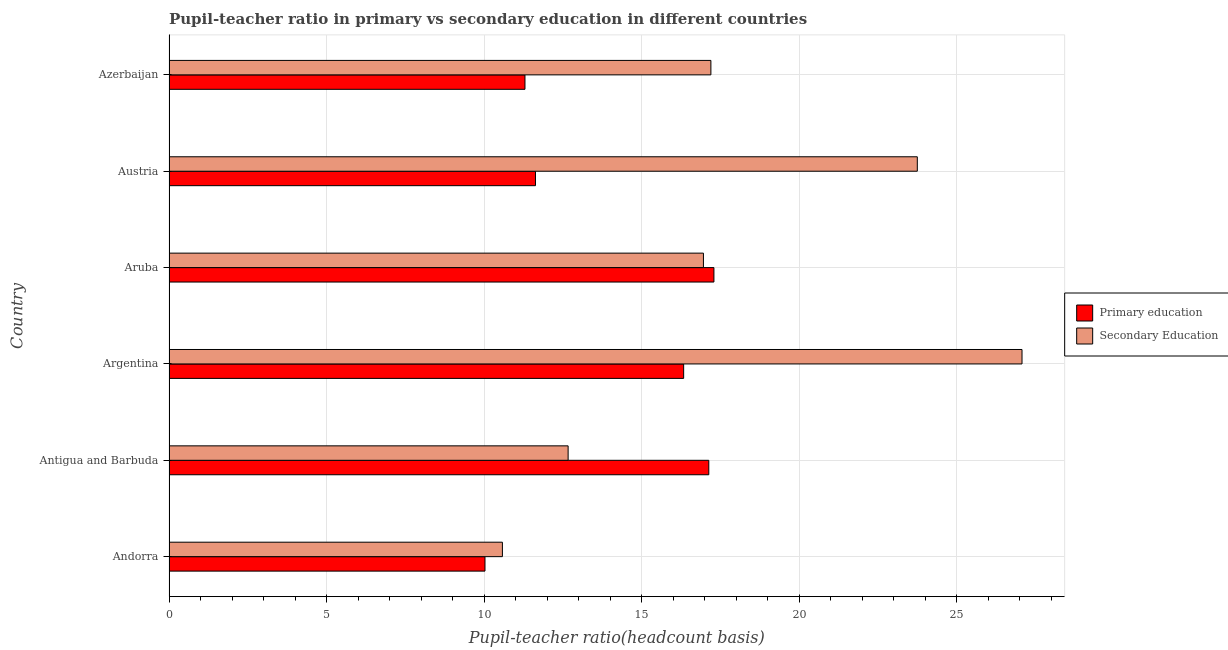How many different coloured bars are there?
Your answer should be very brief. 2. How many groups of bars are there?
Your answer should be very brief. 6. Are the number of bars per tick equal to the number of legend labels?
Your answer should be compact. Yes. Are the number of bars on each tick of the Y-axis equal?
Your answer should be very brief. Yes. How many bars are there on the 3rd tick from the top?
Keep it short and to the point. 2. What is the label of the 5th group of bars from the top?
Provide a short and direct response. Antigua and Barbuda. In how many cases, is the number of bars for a given country not equal to the number of legend labels?
Your response must be concise. 0. What is the pupil-teacher ratio in primary education in Azerbaijan?
Offer a terse response. 11.3. Across all countries, what is the maximum pupil teacher ratio on secondary education?
Offer a very short reply. 27.07. Across all countries, what is the minimum pupil teacher ratio on secondary education?
Keep it short and to the point. 10.58. In which country was the pupil teacher ratio on secondary education maximum?
Your response must be concise. Argentina. In which country was the pupil-teacher ratio in primary education minimum?
Your answer should be very brief. Andorra. What is the total pupil teacher ratio on secondary education in the graph?
Provide a short and direct response. 108.21. What is the difference between the pupil-teacher ratio in primary education in Antigua and Barbuda and that in Argentina?
Your answer should be compact. 0.8. What is the difference between the pupil-teacher ratio in primary education in Antigua and Barbuda and the pupil teacher ratio on secondary education in Aruba?
Your answer should be compact. 0.17. What is the average pupil teacher ratio on secondary education per country?
Provide a short and direct response. 18.04. What is the difference between the pupil-teacher ratio in primary education and pupil teacher ratio on secondary education in Azerbaijan?
Offer a terse response. -5.9. What is the ratio of the pupil teacher ratio on secondary education in Austria to that in Azerbaijan?
Ensure brevity in your answer.  1.38. Is the difference between the pupil-teacher ratio in primary education in Andorra and Azerbaijan greater than the difference between the pupil teacher ratio on secondary education in Andorra and Azerbaijan?
Provide a short and direct response. Yes. What is the difference between the highest and the second highest pupil teacher ratio on secondary education?
Give a very brief answer. 3.32. What is the difference between the highest and the lowest pupil teacher ratio on secondary education?
Ensure brevity in your answer.  16.49. What does the 1st bar from the top in Andorra represents?
Make the answer very short. Secondary Education. What does the 2nd bar from the bottom in Andorra represents?
Your answer should be very brief. Secondary Education. Are all the bars in the graph horizontal?
Your response must be concise. Yes. How many countries are there in the graph?
Ensure brevity in your answer.  6. What is the difference between two consecutive major ticks on the X-axis?
Provide a short and direct response. 5. Does the graph contain any zero values?
Offer a very short reply. No. Where does the legend appear in the graph?
Provide a succinct answer. Center right. What is the title of the graph?
Provide a short and direct response. Pupil-teacher ratio in primary vs secondary education in different countries. What is the label or title of the X-axis?
Make the answer very short. Pupil-teacher ratio(headcount basis). What is the label or title of the Y-axis?
Keep it short and to the point. Country. What is the Pupil-teacher ratio(headcount basis) in Primary education in Andorra?
Keep it short and to the point. 10.03. What is the Pupil-teacher ratio(headcount basis) of Secondary Education in Andorra?
Make the answer very short. 10.58. What is the Pupil-teacher ratio(headcount basis) in Primary education in Antigua and Barbuda?
Provide a succinct answer. 17.13. What is the Pupil-teacher ratio(headcount basis) in Secondary Education in Antigua and Barbuda?
Provide a succinct answer. 12.67. What is the Pupil-teacher ratio(headcount basis) in Primary education in Argentina?
Your answer should be very brief. 16.33. What is the Pupil-teacher ratio(headcount basis) in Secondary Education in Argentina?
Offer a very short reply. 27.07. What is the Pupil-teacher ratio(headcount basis) of Primary education in Aruba?
Your answer should be very brief. 17.29. What is the Pupil-teacher ratio(headcount basis) in Secondary Education in Aruba?
Keep it short and to the point. 16.96. What is the Pupil-teacher ratio(headcount basis) in Primary education in Austria?
Offer a very short reply. 11.63. What is the Pupil-teacher ratio(headcount basis) of Secondary Education in Austria?
Provide a succinct answer. 23.75. What is the Pupil-teacher ratio(headcount basis) of Primary education in Azerbaijan?
Your response must be concise. 11.3. What is the Pupil-teacher ratio(headcount basis) in Secondary Education in Azerbaijan?
Make the answer very short. 17.2. Across all countries, what is the maximum Pupil-teacher ratio(headcount basis) of Primary education?
Keep it short and to the point. 17.29. Across all countries, what is the maximum Pupil-teacher ratio(headcount basis) of Secondary Education?
Offer a very short reply. 27.07. Across all countries, what is the minimum Pupil-teacher ratio(headcount basis) in Primary education?
Provide a short and direct response. 10.03. Across all countries, what is the minimum Pupil-teacher ratio(headcount basis) in Secondary Education?
Make the answer very short. 10.58. What is the total Pupil-teacher ratio(headcount basis) in Primary education in the graph?
Offer a terse response. 83.7. What is the total Pupil-teacher ratio(headcount basis) of Secondary Education in the graph?
Give a very brief answer. 108.21. What is the difference between the Pupil-teacher ratio(headcount basis) of Primary education in Andorra and that in Antigua and Barbuda?
Your answer should be compact. -7.1. What is the difference between the Pupil-teacher ratio(headcount basis) of Secondary Education in Andorra and that in Antigua and Barbuda?
Offer a terse response. -2.09. What is the difference between the Pupil-teacher ratio(headcount basis) of Primary education in Andorra and that in Argentina?
Your answer should be very brief. -6.3. What is the difference between the Pupil-teacher ratio(headcount basis) of Secondary Education in Andorra and that in Argentina?
Your answer should be very brief. -16.49. What is the difference between the Pupil-teacher ratio(headcount basis) of Primary education in Andorra and that in Aruba?
Give a very brief answer. -7.27. What is the difference between the Pupil-teacher ratio(headcount basis) in Secondary Education in Andorra and that in Aruba?
Provide a short and direct response. -6.38. What is the difference between the Pupil-teacher ratio(headcount basis) in Primary education in Andorra and that in Austria?
Offer a very short reply. -1.6. What is the difference between the Pupil-teacher ratio(headcount basis) of Secondary Education in Andorra and that in Austria?
Offer a terse response. -13.17. What is the difference between the Pupil-teacher ratio(headcount basis) in Primary education in Andorra and that in Azerbaijan?
Make the answer very short. -1.27. What is the difference between the Pupil-teacher ratio(headcount basis) of Secondary Education in Andorra and that in Azerbaijan?
Ensure brevity in your answer.  -6.62. What is the difference between the Pupil-teacher ratio(headcount basis) of Primary education in Antigua and Barbuda and that in Argentina?
Give a very brief answer. 0.8. What is the difference between the Pupil-teacher ratio(headcount basis) in Secondary Education in Antigua and Barbuda and that in Argentina?
Offer a terse response. -14.4. What is the difference between the Pupil-teacher ratio(headcount basis) in Primary education in Antigua and Barbuda and that in Aruba?
Your response must be concise. -0.16. What is the difference between the Pupil-teacher ratio(headcount basis) in Secondary Education in Antigua and Barbuda and that in Aruba?
Your answer should be compact. -4.29. What is the difference between the Pupil-teacher ratio(headcount basis) of Primary education in Antigua and Barbuda and that in Austria?
Offer a terse response. 5.5. What is the difference between the Pupil-teacher ratio(headcount basis) of Secondary Education in Antigua and Barbuda and that in Austria?
Your response must be concise. -11.08. What is the difference between the Pupil-teacher ratio(headcount basis) in Primary education in Antigua and Barbuda and that in Azerbaijan?
Provide a short and direct response. 5.83. What is the difference between the Pupil-teacher ratio(headcount basis) in Secondary Education in Antigua and Barbuda and that in Azerbaijan?
Your answer should be compact. -4.53. What is the difference between the Pupil-teacher ratio(headcount basis) of Primary education in Argentina and that in Aruba?
Your answer should be compact. -0.96. What is the difference between the Pupil-teacher ratio(headcount basis) of Secondary Education in Argentina and that in Aruba?
Provide a succinct answer. 10.11. What is the difference between the Pupil-teacher ratio(headcount basis) in Primary education in Argentina and that in Austria?
Ensure brevity in your answer.  4.7. What is the difference between the Pupil-teacher ratio(headcount basis) in Secondary Education in Argentina and that in Austria?
Provide a short and direct response. 3.32. What is the difference between the Pupil-teacher ratio(headcount basis) in Primary education in Argentina and that in Azerbaijan?
Your answer should be compact. 5.04. What is the difference between the Pupil-teacher ratio(headcount basis) of Secondary Education in Argentina and that in Azerbaijan?
Provide a short and direct response. 9.87. What is the difference between the Pupil-teacher ratio(headcount basis) of Primary education in Aruba and that in Austria?
Your answer should be compact. 5.66. What is the difference between the Pupil-teacher ratio(headcount basis) in Secondary Education in Aruba and that in Austria?
Your answer should be very brief. -6.79. What is the difference between the Pupil-teacher ratio(headcount basis) of Primary education in Aruba and that in Azerbaijan?
Offer a terse response. 6. What is the difference between the Pupil-teacher ratio(headcount basis) of Secondary Education in Aruba and that in Azerbaijan?
Your response must be concise. -0.24. What is the difference between the Pupil-teacher ratio(headcount basis) of Secondary Education in Austria and that in Azerbaijan?
Provide a short and direct response. 6.55. What is the difference between the Pupil-teacher ratio(headcount basis) in Primary education in Andorra and the Pupil-teacher ratio(headcount basis) in Secondary Education in Antigua and Barbuda?
Your answer should be compact. -2.64. What is the difference between the Pupil-teacher ratio(headcount basis) in Primary education in Andorra and the Pupil-teacher ratio(headcount basis) in Secondary Education in Argentina?
Offer a very short reply. -17.04. What is the difference between the Pupil-teacher ratio(headcount basis) in Primary education in Andorra and the Pupil-teacher ratio(headcount basis) in Secondary Education in Aruba?
Offer a terse response. -6.93. What is the difference between the Pupil-teacher ratio(headcount basis) in Primary education in Andorra and the Pupil-teacher ratio(headcount basis) in Secondary Education in Austria?
Make the answer very short. -13.72. What is the difference between the Pupil-teacher ratio(headcount basis) of Primary education in Andorra and the Pupil-teacher ratio(headcount basis) of Secondary Education in Azerbaijan?
Keep it short and to the point. -7.17. What is the difference between the Pupil-teacher ratio(headcount basis) of Primary education in Antigua and Barbuda and the Pupil-teacher ratio(headcount basis) of Secondary Education in Argentina?
Offer a very short reply. -9.94. What is the difference between the Pupil-teacher ratio(headcount basis) in Primary education in Antigua and Barbuda and the Pupil-teacher ratio(headcount basis) in Secondary Education in Aruba?
Keep it short and to the point. 0.17. What is the difference between the Pupil-teacher ratio(headcount basis) in Primary education in Antigua and Barbuda and the Pupil-teacher ratio(headcount basis) in Secondary Education in Austria?
Make the answer very short. -6.62. What is the difference between the Pupil-teacher ratio(headcount basis) of Primary education in Antigua and Barbuda and the Pupil-teacher ratio(headcount basis) of Secondary Education in Azerbaijan?
Offer a terse response. -0.07. What is the difference between the Pupil-teacher ratio(headcount basis) in Primary education in Argentina and the Pupil-teacher ratio(headcount basis) in Secondary Education in Aruba?
Offer a very short reply. -0.63. What is the difference between the Pupil-teacher ratio(headcount basis) in Primary education in Argentina and the Pupil-teacher ratio(headcount basis) in Secondary Education in Austria?
Provide a short and direct response. -7.41. What is the difference between the Pupil-teacher ratio(headcount basis) in Primary education in Argentina and the Pupil-teacher ratio(headcount basis) in Secondary Education in Azerbaijan?
Your answer should be compact. -0.86. What is the difference between the Pupil-teacher ratio(headcount basis) in Primary education in Aruba and the Pupil-teacher ratio(headcount basis) in Secondary Education in Austria?
Keep it short and to the point. -6.45. What is the difference between the Pupil-teacher ratio(headcount basis) of Primary education in Aruba and the Pupil-teacher ratio(headcount basis) of Secondary Education in Azerbaijan?
Offer a very short reply. 0.1. What is the difference between the Pupil-teacher ratio(headcount basis) of Primary education in Austria and the Pupil-teacher ratio(headcount basis) of Secondary Education in Azerbaijan?
Your answer should be very brief. -5.57. What is the average Pupil-teacher ratio(headcount basis) in Primary education per country?
Give a very brief answer. 13.95. What is the average Pupil-teacher ratio(headcount basis) of Secondary Education per country?
Provide a succinct answer. 18.04. What is the difference between the Pupil-teacher ratio(headcount basis) of Primary education and Pupil-teacher ratio(headcount basis) of Secondary Education in Andorra?
Provide a succinct answer. -0.55. What is the difference between the Pupil-teacher ratio(headcount basis) of Primary education and Pupil-teacher ratio(headcount basis) of Secondary Education in Antigua and Barbuda?
Make the answer very short. 4.46. What is the difference between the Pupil-teacher ratio(headcount basis) of Primary education and Pupil-teacher ratio(headcount basis) of Secondary Education in Argentina?
Offer a very short reply. -10.74. What is the difference between the Pupil-teacher ratio(headcount basis) in Primary education and Pupil-teacher ratio(headcount basis) in Secondary Education in Aruba?
Make the answer very short. 0.33. What is the difference between the Pupil-teacher ratio(headcount basis) of Primary education and Pupil-teacher ratio(headcount basis) of Secondary Education in Austria?
Ensure brevity in your answer.  -12.12. What is the difference between the Pupil-teacher ratio(headcount basis) of Primary education and Pupil-teacher ratio(headcount basis) of Secondary Education in Azerbaijan?
Offer a terse response. -5.9. What is the ratio of the Pupil-teacher ratio(headcount basis) of Primary education in Andorra to that in Antigua and Barbuda?
Provide a short and direct response. 0.59. What is the ratio of the Pupil-teacher ratio(headcount basis) of Secondary Education in Andorra to that in Antigua and Barbuda?
Your answer should be compact. 0.84. What is the ratio of the Pupil-teacher ratio(headcount basis) of Primary education in Andorra to that in Argentina?
Provide a short and direct response. 0.61. What is the ratio of the Pupil-teacher ratio(headcount basis) of Secondary Education in Andorra to that in Argentina?
Give a very brief answer. 0.39. What is the ratio of the Pupil-teacher ratio(headcount basis) in Primary education in Andorra to that in Aruba?
Offer a very short reply. 0.58. What is the ratio of the Pupil-teacher ratio(headcount basis) in Secondary Education in Andorra to that in Aruba?
Provide a succinct answer. 0.62. What is the ratio of the Pupil-teacher ratio(headcount basis) of Primary education in Andorra to that in Austria?
Your response must be concise. 0.86. What is the ratio of the Pupil-teacher ratio(headcount basis) of Secondary Education in Andorra to that in Austria?
Give a very brief answer. 0.45. What is the ratio of the Pupil-teacher ratio(headcount basis) in Primary education in Andorra to that in Azerbaijan?
Offer a very short reply. 0.89. What is the ratio of the Pupil-teacher ratio(headcount basis) in Secondary Education in Andorra to that in Azerbaijan?
Ensure brevity in your answer.  0.62. What is the ratio of the Pupil-teacher ratio(headcount basis) of Primary education in Antigua and Barbuda to that in Argentina?
Your response must be concise. 1.05. What is the ratio of the Pupil-teacher ratio(headcount basis) of Secondary Education in Antigua and Barbuda to that in Argentina?
Make the answer very short. 0.47. What is the ratio of the Pupil-teacher ratio(headcount basis) in Primary education in Antigua and Barbuda to that in Aruba?
Offer a terse response. 0.99. What is the ratio of the Pupil-teacher ratio(headcount basis) of Secondary Education in Antigua and Barbuda to that in Aruba?
Offer a very short reply. 0.75. What is the ratio of the Pupil-teacher ratio(headcount basis) of Primary education in Antigua and Barbuda to that in Austria?
Your answer should be very brief. 1.47. What is the ratio of the Pupil-teacher ratio(headcount basis) in Secondary Education in Antigua and Barbuda to that in Austria?
Your answer should be compact. 0.53. What is the ratio of the Pupil-teacher ratio(headcount basis) of Primary education in Antigua and Barbuda to that in Azerbaijan?
Your answer should be very brief. 1.52. What is the ratio of the Pupil-teacher ratio(headcount basis) of Secondary Education in Antigua and Barbuda to that in Azerbaijan?
Your answer should be compact. 0.74. What is the ratio of the Pupil-teacher ratio(headcount basis) in Primary education in Argentina to that in Aruba?
Give a very brief answer. 0.94. What is the ratio of the Pupil-teacher ratio(headcount basis) of Secondary Education in Argentina to that in Aruba?
Make the answer very short. 1.6. What is the ratio of the Pupil-teacher ratio(headcount basis) of Primary education in Argentina to that in Austria?
Make the answer very short. 1.4. What is the ratio of the Pupil-teacher ratio(headcount basis) in Secondary Education in Argentina to that in Austria?
Offer a terse response. 1.14. What is the ratio of the Pupil-teacher ratio(headcount basis) in Primary education in Argentina to that in Azerbaijan?
Keep it short and to the point. 1.45. What is the ratio of the Pupil-teacher ratio(headcount basis) in Secondary Education in Argentina to that in Azerbaijan?
Your answer should be compact. 1.57. What is the ratio of the Pupil-teacher ratio(headcount basis) in Primary education in Aruba to that in Austria?
Provide a short and direct response. 1.49. What is the ratio of the Pupil-teacher ratio(headcount basis) of Secondary Education in Aruba to that in Austria?
Offer a very short reply. 0.71. What is the ratio of the Pupil-teacher ratio(headcount basis) of Primary education in Aruba to that in Azerbaijan?
Provide a succinct answer. 1.53. What is the ratio of the Pupil-teacher ratio(headcount basis) of Secondary Education in Aruba to that in Azerbaijan?
Give a very brief answer. 0.99. What is the ratio of the Pupil-teacher ratio(headcount basis) in Primary education in Austria to that in Azerbaijan?
Offer a terse response. 1.03. What is the ratio of the Pupil-teacher ratio(headcount basis) of Secondary Education in Austria to that in Azerbaijan?
Give a very brief answer. 1.38. What is the difference between the highest and the second highest Pupil-teacher ratio(headcount basis) of Primary education?
Keep it short and to the point. 0.16. What is the difference between the highest and the second highest Pupil-teacher ratio(headcount basis) in Secondary Education?
Give a very brief answer. 3.32. What is the difference between the highest and the lowest Pupil-teacher ratio(headcount basis) of Primary education?
Give a very brief answer. 7.27. What is the difference between the highest and the lowest Pupil-teacher ratio(headcount basis) in Secondary Education?
Provide a short and direct response. 16.49. 